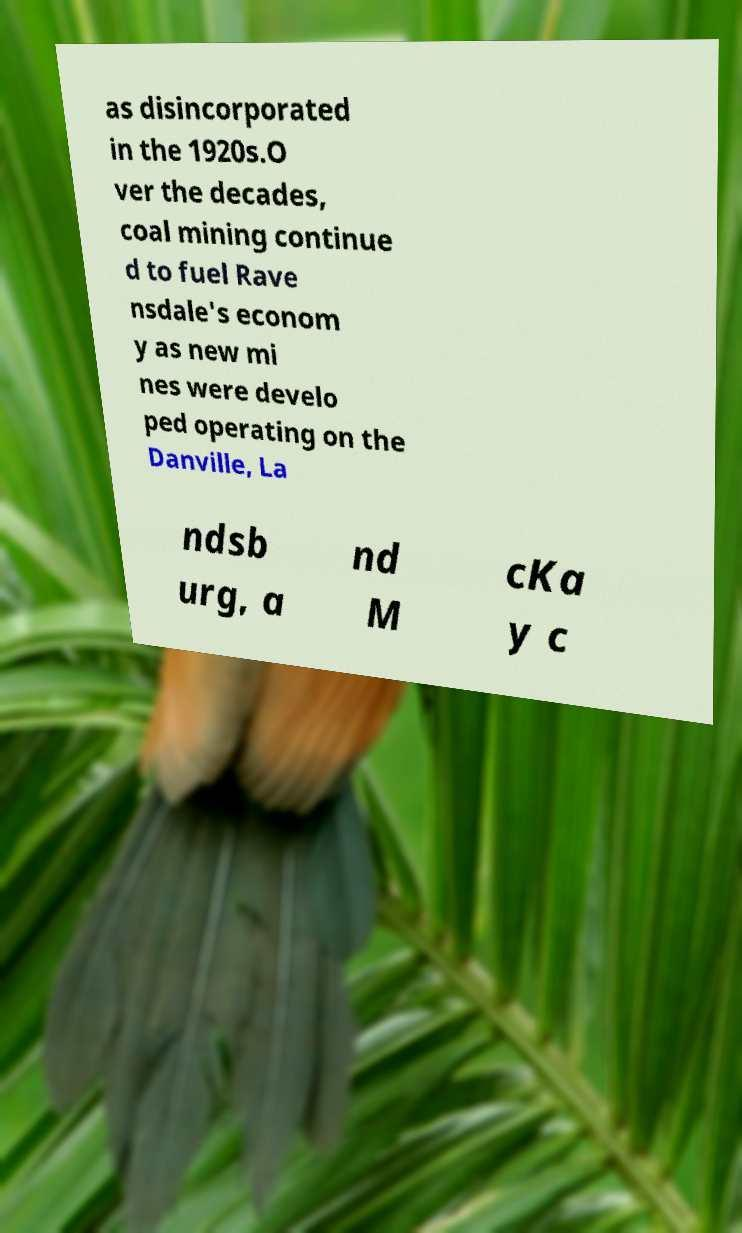Can you accurately transcribe the text from the provided image for me? as disincorporated in the 1920s.O ver the decades, coal mining continue d to fuel Rave nsdale's econom y as new mi nes were develo ped operating on the Danville, La ndsb urg, a nd M cKa y c 